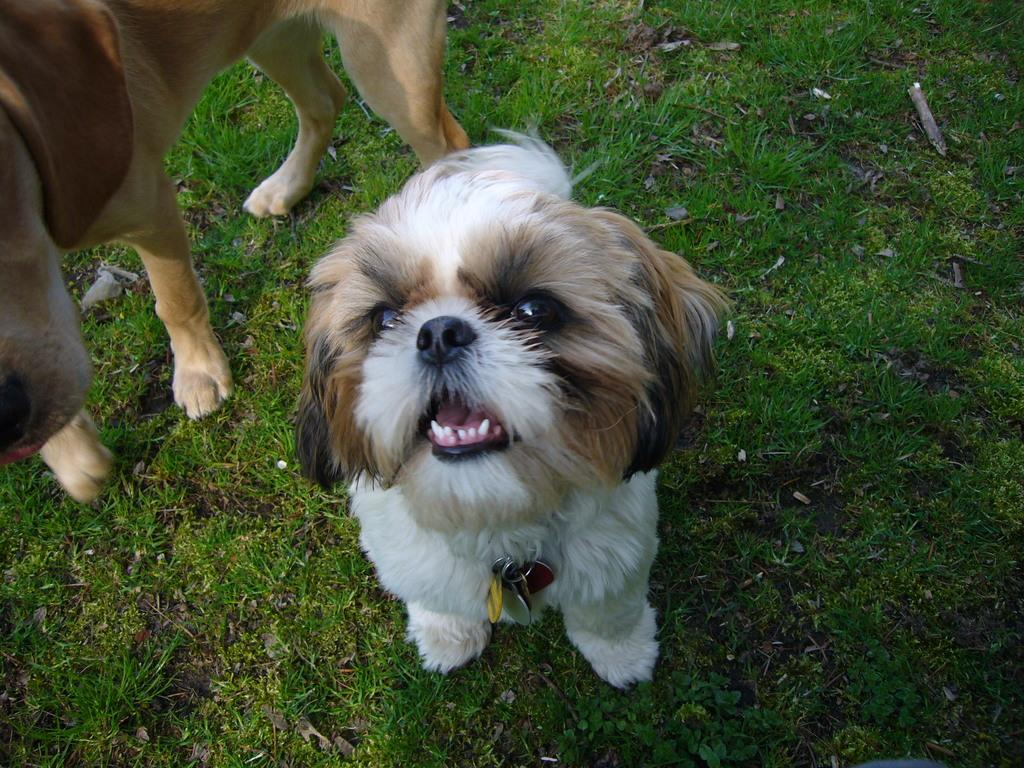What type of animal can be seen in the image? There is a small dog in the image. Where is the small dog located? The small dog is on the ground. Are there any other animals in the image? Yes, there is another dog in the image. How are the two dogs positioned in relation to each other? The other dog is beside the small dog. What type of surface is the small dog standing on? There is grass on the ground in the image. What type of wax is being used to create a balloon sculpture in the image? There is no wax or balloon sculpture present in the image. Is there any indication of a war or conflict in the image? No, there is no indication of a war or conflict in the image. 